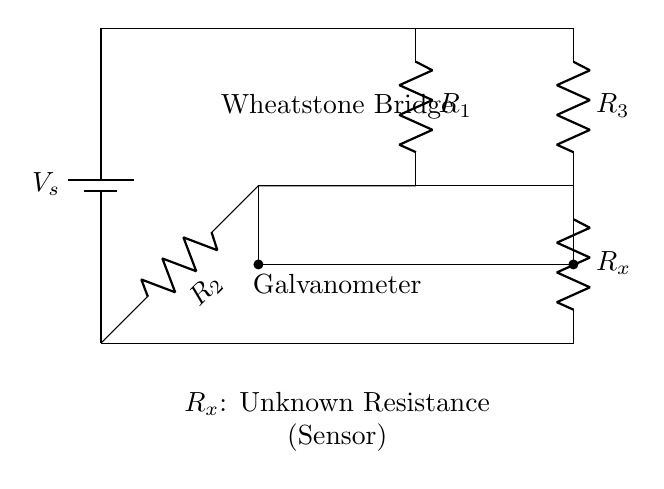What is the voltage source in this circuit? The voltage source in the Wheatstone bridge is indicated by the battery symbol, labeled as Vs. This represents the power supplied to the circuit.
Answer: Vs What does Rx represent in this circuit diagram? Rx, positioned in the lower section of the bridge, represents the unknown resistance. It is often used for measuring or calibrating sensors.
Answer: Unknown Resistance How many resistors are present in the Wheatstone bridge? The circuit diagram shows four resistors: R1, R2, R3, and Rx, which form two pairs in the bridge configuration.
Answer: Four What is the role of the galvanometer in this circuit? The galvanometer measures the current flowing through the bridge circuit. It indicates whether the bridge is balanced based on the detected current.
Answer: Current measurement If the bridge is balanced, what can be said about the ratio of the resistances? When balanced, the ratio of R1 to R2 equals the ratio of Rx to R3. This state allows for precise resistance measurement of Rx.
Answer: R1/R2 = Rx/R3 What is the purpose of the Wheatstone bridge in sensor calibration? The Wheatstone bridge offers precise resistance measurements, allowing for accurate calibration of sensors by comparing unknown resistance with known values.
Answer: Precise resistance measurement What happens if Rx is equal to R3 in the circuit? If Rx equals R3, the bridge will be balanced, resulting in the galvanometer reading zero current, indicating no potential difference across it.
Answer: Balanced bridge 